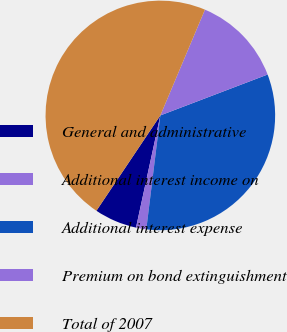<chart> <loc_0><loc_0><loc_500><loc_500><pie_chart><fcel>General and administrative<fcel>Additional interest income on<fcel>Additional interest expense<fcel>Premium on bond extinguishment<fcel>Total of 2007<nl><fcel>6.0%<fcel>1.45%<fcel>32.75%<fcel>12.85%<fcel>46.95%<nl></chart> 